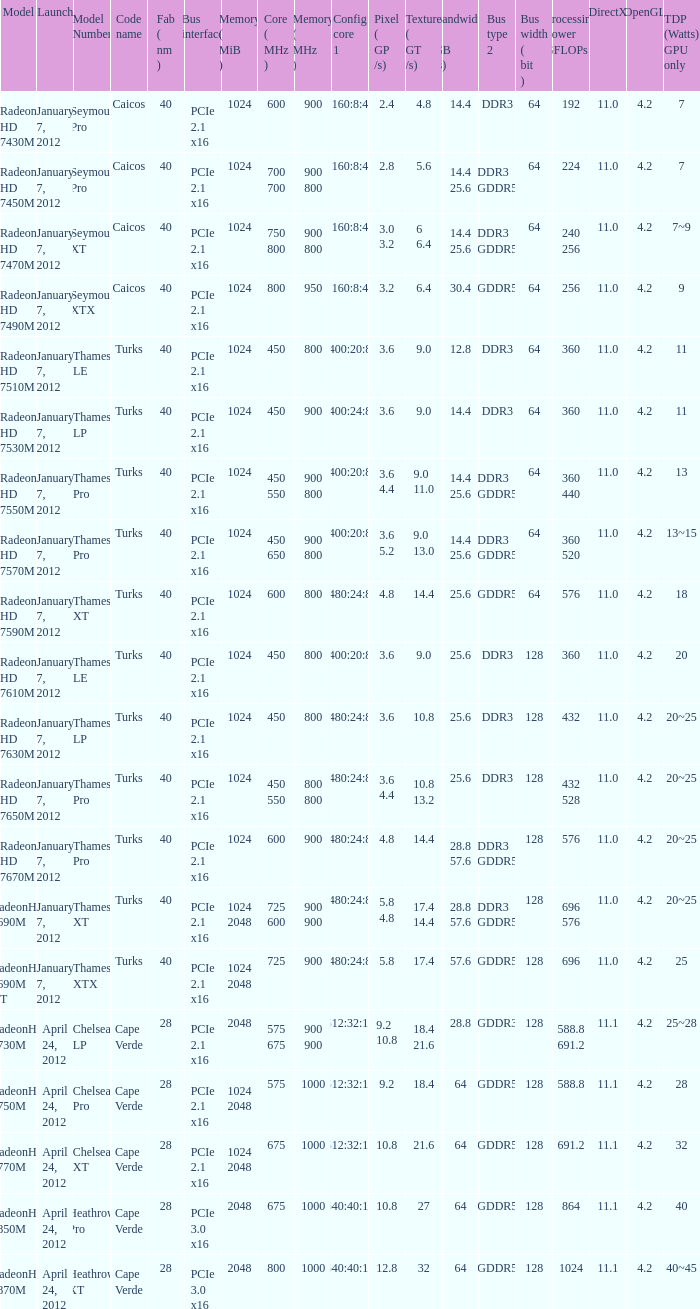What was the model's DirectX if it has a Core of 700 700 mhz? 11.0. 